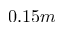Convert formula to latex. <formula><loc_0><loc_0><loc_500><loc_500>0 . 1 5 m</formula> 